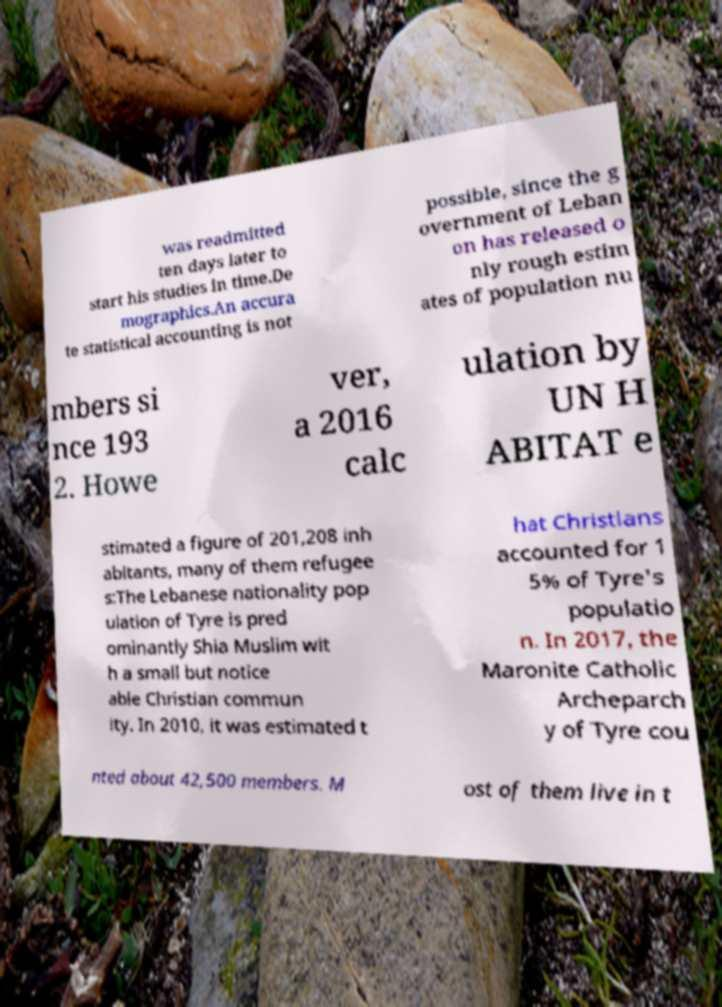I need the written content from this picture converted into text. Can you do that? was readmitted ten days later to start his studies in time.De mographics.An accura te statistical accounting is not possible, since the g overnment of Leban on has released o nly rough estim ates of population nu mbers si nce 193 2. Howe ver, a 2016 calc ulation by UN H ABITAT e stimated a figure of 201,208 inh abitants, many of them refugee s:The Lebanese nationality pop ulation of Tyre is pred ominantly Shia Muslim wit h a small but notice able Christian commun ity. In 2010, it was estimated t hat Christians accounted for 1 5% of Tyre's populatio n. In 2017, the Maronite Catholic Archeparch y of Tyre cou nted about 42,500 members. M ost of them live in t 